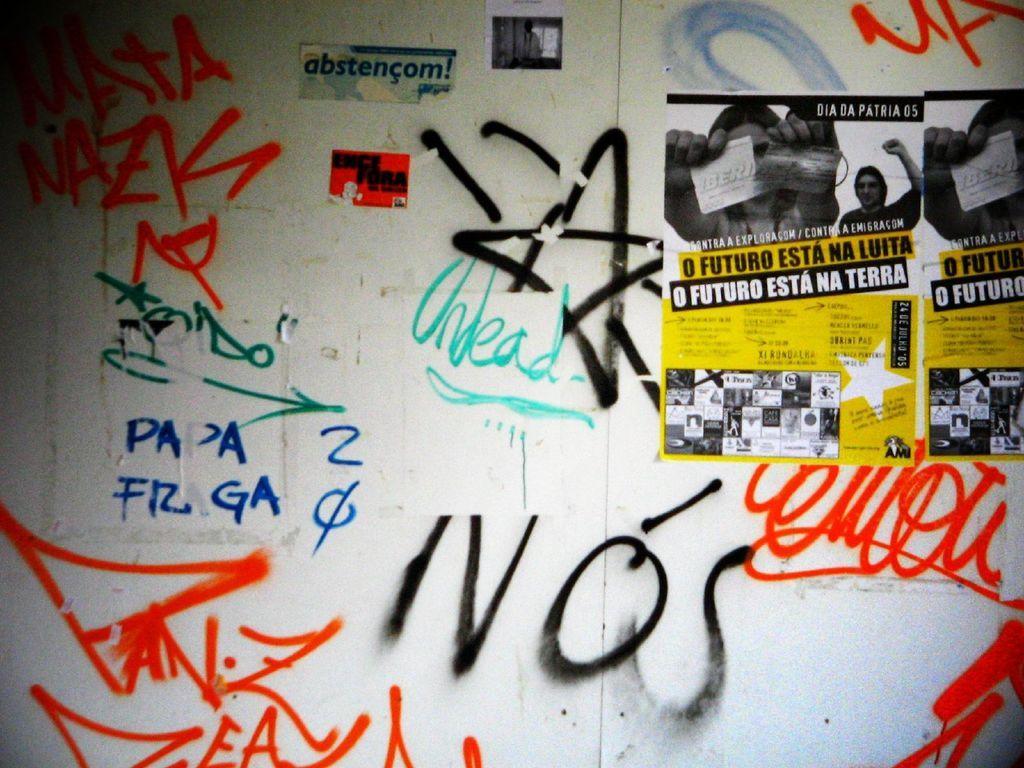Describe this image in one or two sentences. In this picture I can see couple posters with some text and I can see text on the wall. 